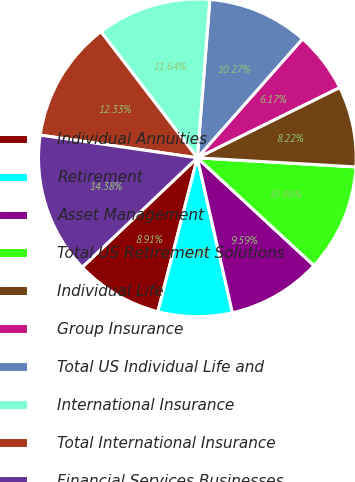<chart> <loc_0><loc_0><loc_500><loc_500><pie_chart><fcel>Individual Annuities<fcel>Retirement<fcel>Asset Management<fcel>Total US Retirement Solutions<fcel>Individual Life<fcel>Group Insurance<fcel>Total US Individual Life and<fcel>International Insurance<fcel>Total International Insurance<fcel>Financial Services Businesses<nl><fcel>8.91%<fcel>7.54%<fcel>9.59%<fcel>10.96%<fcel>8.22%<fcel>6.17%<fcel>10.27%<fcel>11.64%<fcel>12.33%<fcel>14.38%<nl></chart> 